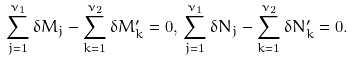<formula> <loc_0><loc_0><loc_500><loc_500>\sum _ { j = 1 } ^ { \nu _ { 1 } } \delta M _ { j } - \sum _ { k = 1 } ^ { \nu _ { 2 } } \delta M _ { k } ^ { \prime } = 0 , \, \sum _ { j = 1 } ^ { \nu _ { 1 } } \delta N _ { j } - \sum _ { k = 1 } ^ { \nu _ { 2 } } \delta N _ { k } ^ { \prime } = 0 .</formula> 